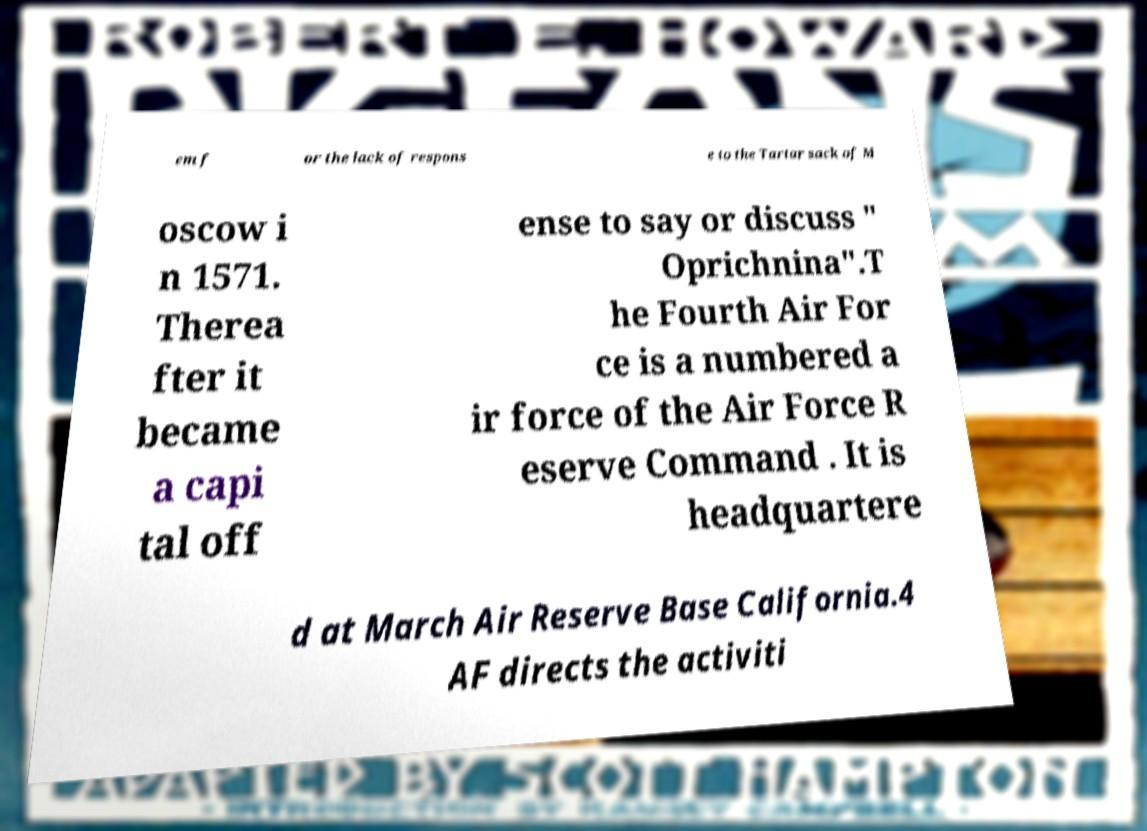What messages or text are displayed in this image? I need them in a readable, typed format. em f or the lack of respons e to the Tartar sack of M oscow i n 1571. Therea fter it became a capi tal off ense to say or discuss " Oprichnina".T he Fourth Air For ce is a numbered a ir force of the Air Force R eserve Command . It is headquartere d at March Air Reserve Base California.4 AF directs the activiti 